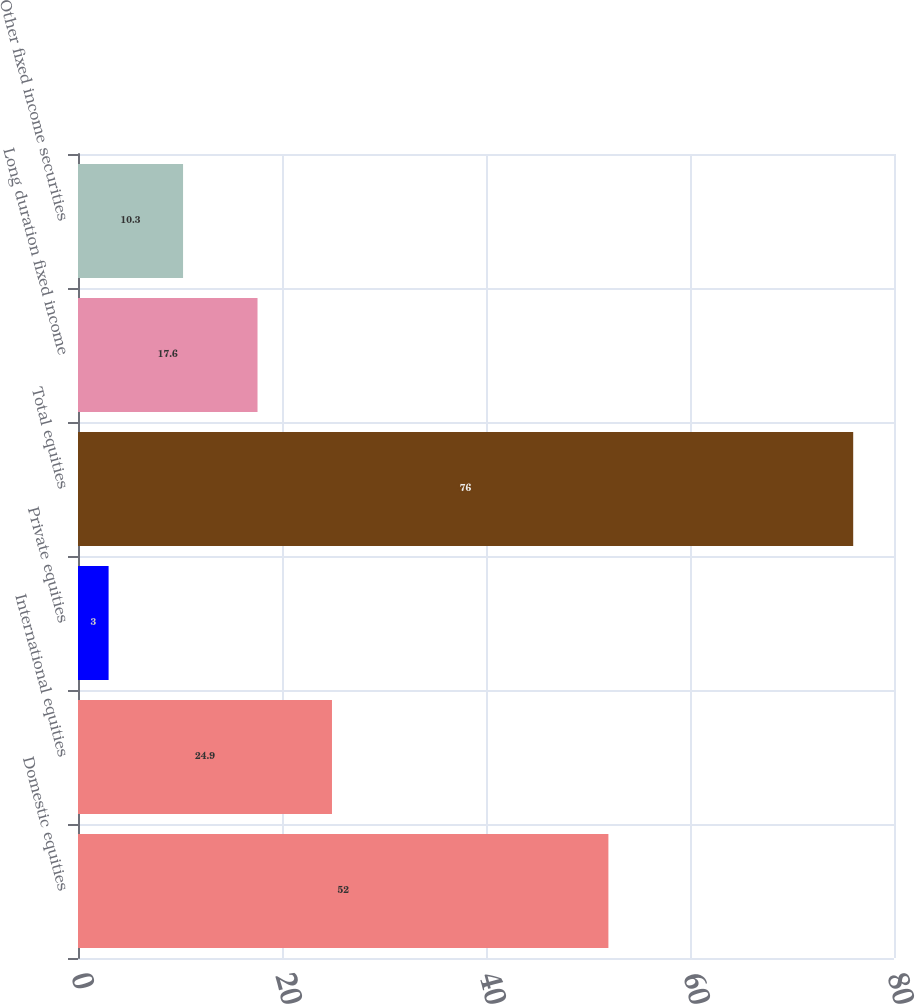Convert chart to OTSL. <chart><loc_0><loc_0><loc_500><loc_500><bar_chart><fcel>Domestic equities<fcel>International equities<fcel>Private equities<fcel>Total equities<fcel>Long duration fixed income<fcel>Other fixed income securities<nl><fcel>52<fcel>24.9<fcel>3<fcel>76<fcel>17.6<fcel>10.3<nl></chart> 